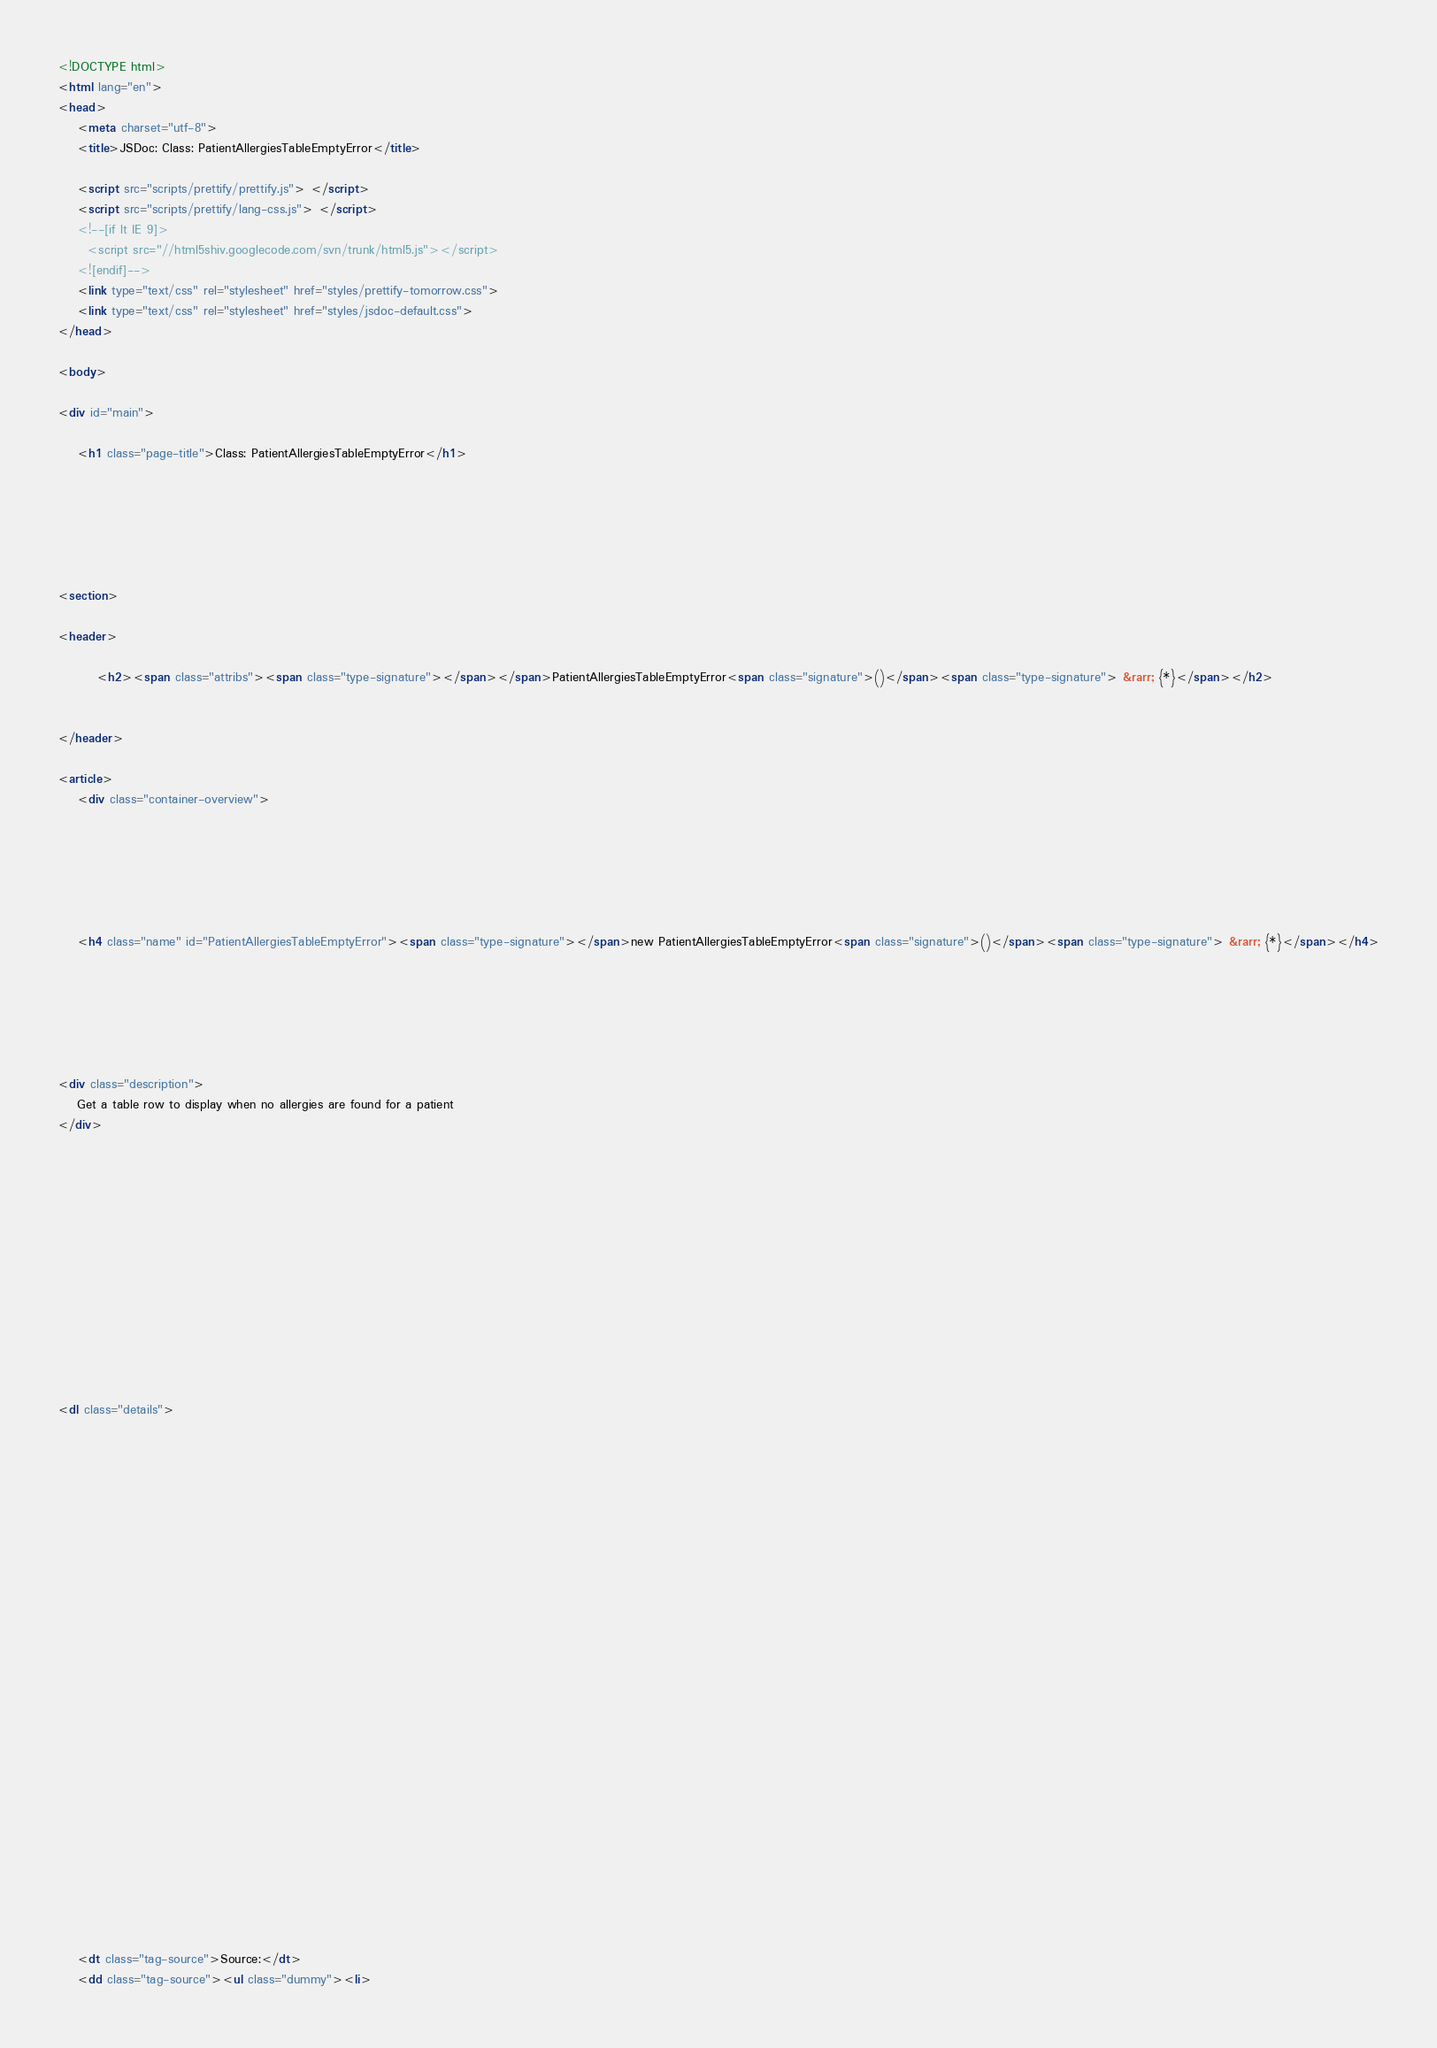Convert code to text. <code><loc_0><loc_0><loc_500><loc_500><_HTML_><!DOCTYPE html>
<html lang="en">
<head>
    <meta charset="utf-8">
    <title>JSDoc: Class: PatientAllergiesTableEmptyError</title>

    <script src="scripts/prettify/prettify.js"> </script>
    <script src="scripts/prettify/lang-css.js"> </script>
    <!--[if lt IE 9]>
      <script src="//html5shiv.googlecode.com/svn/trunk/html5.js"></script>
    <![endif]-->
    <link type="text/css" rel="stylesheet" href="styles/prettify-tomorrow.css">
    <link type="text/css" rel="stylesheet" href="styles/jsdoc-default.css">
</head>

<body>

<div id="main">

    <h1 class="page-title">Class: PatientAllergiesTableEmptyError</h1>

    




<section>

<header>
    
        <h2><span class="attribs"><span class="type-signature"></span></span>PatientAllergiesTableEmptyError<span class="signature">()</span><span class="type-signature"> &rarr; {*}</span></h2>
        
    
</header>

<article>
    <div class="container-overview">
    
        

    

    
    <h4 class="name" id="PatientAllergiesTableEmptyError"><span class="type-signature"></span>new PatientAllergiesTableEmptyError<span class="signature">()</span><span class="type-signature"> &rarr; {*}</span></h4>
    

    



<div class="description">
    Get a table row to display when no allergies are found for a patient
</div>













<dl class="details">

    

    

    

    

    

    

    

    

    

    

    

    

    
    <dt class="tag-source">Source:</dt>
    <dd class="tag-source"><ul class="dummy"><li></code> 